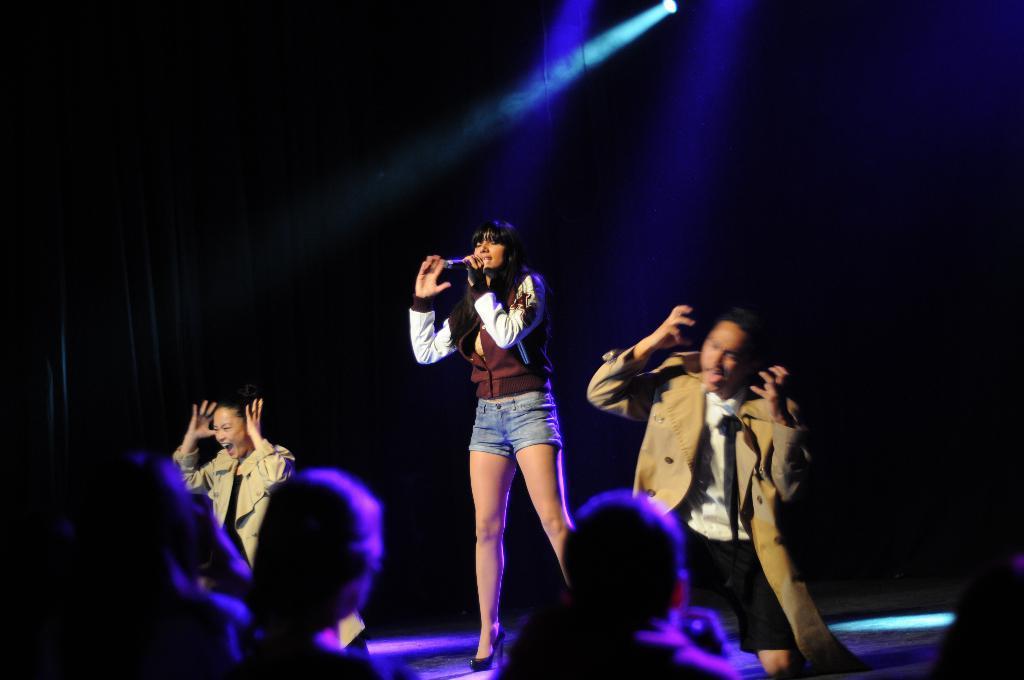How would you summarize this image in a sentence or two? In the center of the image we can see a lady standing and holding a mic in her hand, may be she is singing and there are two people performing. At the bottom there is crowd. At the top there are lights. 